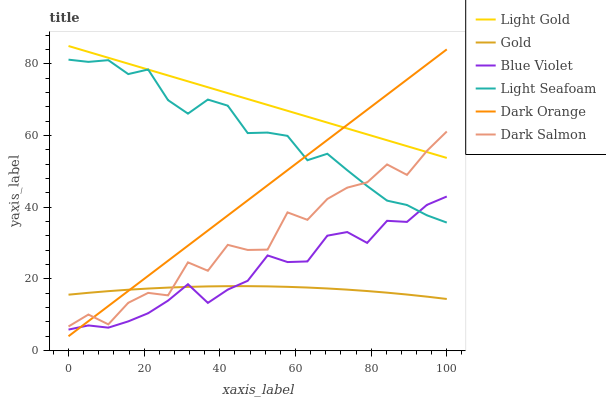Does Gold have the minimum area under the curve?
Answer yes or no. Yes. Does Light Gold have the maximum area under the curve?
Answer yes or no. Yes. Does Dark Salmon have the minimum area under the curve?
Answer yes or no. No. Does Dark Salmon have the maximum area under the curve?
Answer yes or no. No. Is Dark Orange the smoothest?
Answer yes or no. Yes. Is Dark Salmon the roughest?
Answer yes or no. Yes. Is Gold the smoothest?
Answer yes or no. No. Is Gold the roughest?
Answer yes or no. No. Does Gold have the lowest value?
Answer yes or no. No. Does Light Gold have the highest value?
Answer yes or no. Yes. Does Dark Salmon have the highest value?
Answer yes or no. No. Is Blue Violet less than Dark Salmon?
Answer yes or no. Yes. Is Dark Salmon greater than Blue Violet?
Answer yes or no. Yes. Does Blue Violet intersect Light Seafoam?
Answer yes or no. Yes. Is Blue Violet less than Light Seafoam?
Answer yes or no. No. Is Blue Violet greater than Light Seafoam?
Answer yes or no. No. Does Blue Violet intersect Dark Salmon?
Answer yes or no. No. 